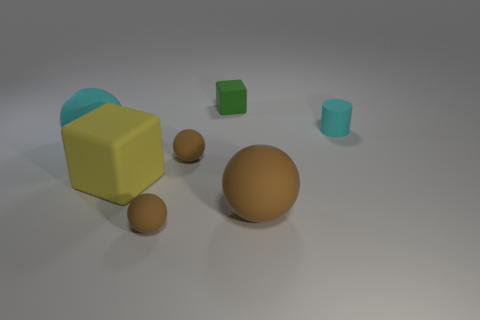There is a cyan rubber object that is on the right side of the tiny green matte thing; what number of tiny brown rubber things are left of it?
Keep it short and to the point. 2. Are there more rubber cubes that are behind the big brown matte ball than small cyan cylinders?
Ensure brevity in your answer.  Yes. What size is the object that is both to the right of the tiny rubber cube and in front of the tiny cyan rubber cylinder?
Provide a succinct answer. Large. There is a matte thing that is both behind the large brown object and to the right of the small green object; what shape is it?
Ensure brevity in your answer.  Cylinder. Are there any large rubber things that are to the left of the block that is in front of the matte cylinder that is to the right of the big brown sphere?
Offer a terse response. Yes. What number of objects are small rubber objects to the right of the tiny green thing or small objects that are to the right of the big brown matte sphere?
Your answer should be compact. 1. Are the thing that is behind the cyan matte cylinder and the large yellow cube made of the same material?
Offer a very short reply. Yes. There is a tiny thing that is behind the large cyan rubber object and in front of the small matte block; what is its material?
Make the answer very short. Rubber. There is a cube that is in front of the cyan thing that is on the right side of the green cube; what is its color?
Make the answer very short. Yellow. What color is the small rubber block behind the rubber cube that is in front of the cube behind the cyan rubber sphere?
Keep it short and to the point. Green. 